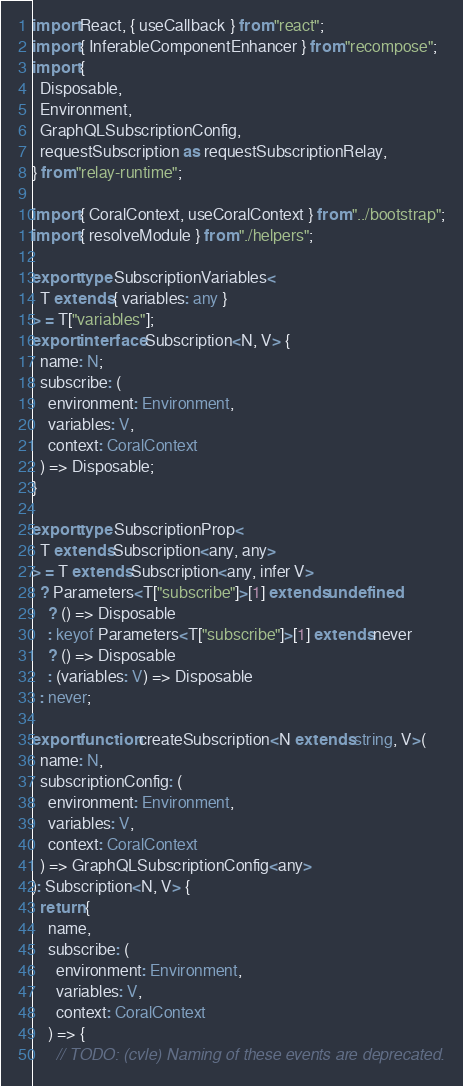Convert code to text. <code><loc_0><loc_0><loc_500><loc_500><_TypeScript_>import React, { useCallback } from "react";
import { InferableComponentEnhancer } from "recompose";
import {
  Disposable,
  Environment,
  GraphQLSubscriptionConfig,
  requestSubscription as requestSubscriptionRelay,
} from "relay-runtime";

import { CoralContext, useCoralContext } from "../bootstrap";
import { resolveModule } from "./helpers";

export type SubscriptionVariables<
  T extends { variables: any }
> = T["variables"];
export interface Subscription<N, V> {
  name: N;
  subscribe: (
    environment: Environment,
    variables: V,
    context: CoralContext
  ) => Disposable;
}

export type SubscriptionProp<
  T extends Subscription<any, any>
> = T extends Subscription<any, infer V>
  ? Parameters<T["subscribe"]>[1] extends undefined
    ? () => Disposable
    : keyof Parameters<T["subscribe"]>[1] extends never
    ? () => Disposable
    : (variables: V) => Disposable
  : never;

export function createSubscription<N extends string, V>(
  name: N,
  subscriptionConfig: (
    environment: Environment,
    variables: V,
    context: CoralContext
  ) => GraphQLSubscriptionConfig<any>
): Subscription<N, V> {
  return {
    name,
    subscribe: (
      environment: Environment,
      variables: V,
      context: CoralContext
    ) => {
      // TODO: (cvle) Naming of these events are deprecated.</code> 